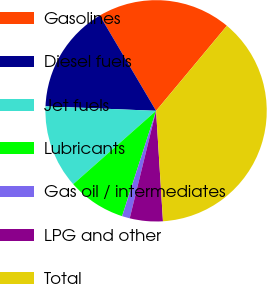Convert chart to OTSL. <chart><loc_0><loc_0><loc_500><loc_500><pie_chart><fcel>Gasolines<fcel>Diesel fuels<fcel>Jet fuels<fcel>Lubricants<fcel>Gas oil / intermediates<fcel>LPG and other<fcel>Total<nl><fcel>19.54%<fcel>15.86%<fcel>12.18%<fcel>8.5%<fcel>1.14%<fcel>4.82%<fcel>37.95%<nl></chart> 